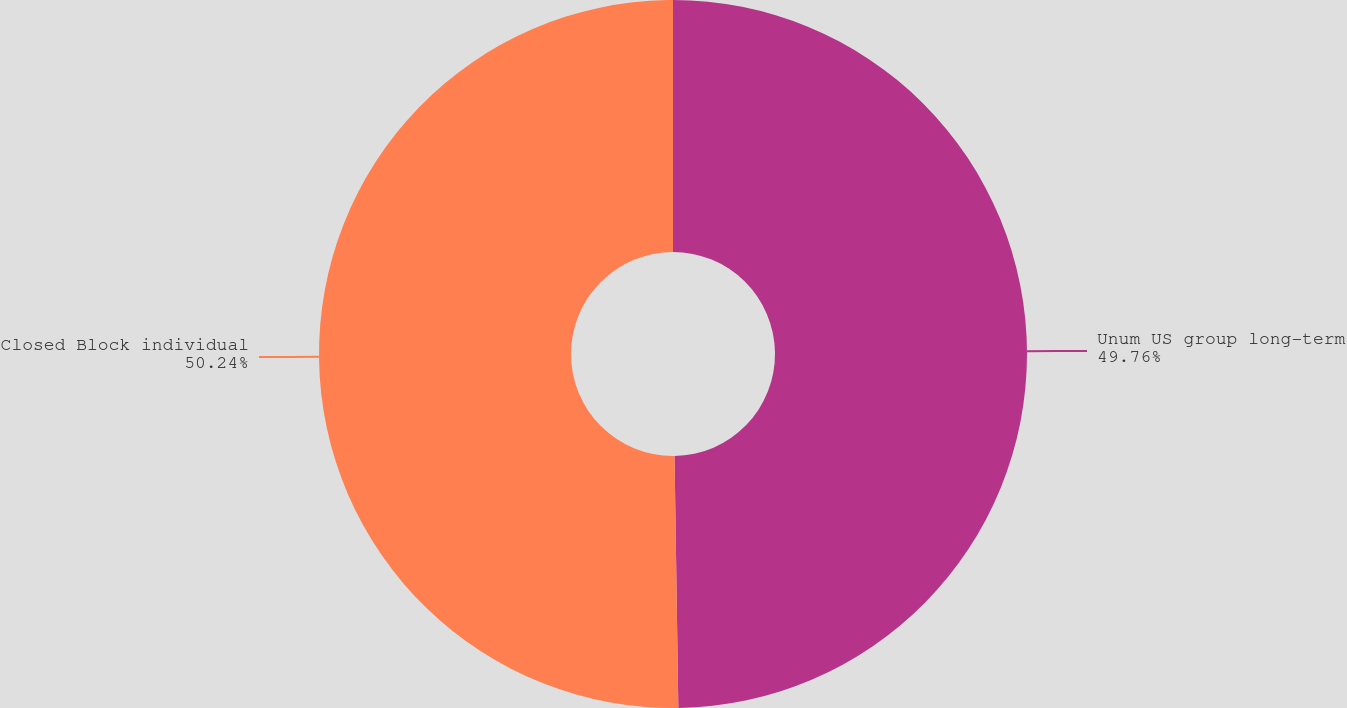Convert chart. <chart><loc_0><loc_0><loc_500><loc_500><pie_chart><fcel>Unum US group long-term<fcel>Closed Block individual<nl><fcel>49.76%<fcel>50.24%<nl></chart> 